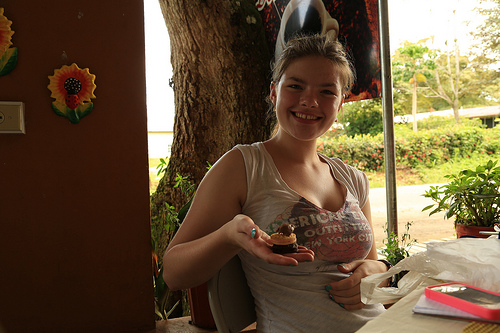<image>
Is there a phone above the table? No. The phone is not positioned above the table. The vertical arrangement shows a different relationship. 